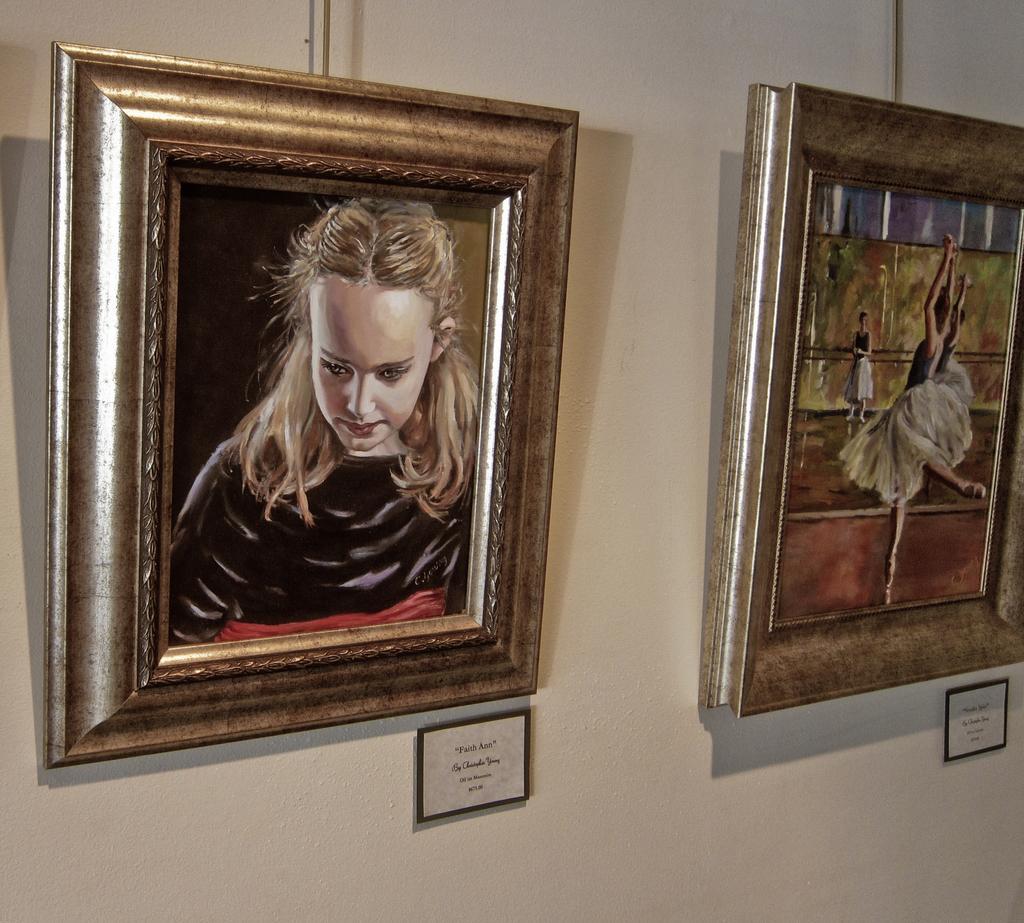How would you summarize this image in a sentence or two? In this image we can see two picture frames with painting and under the frames there are boards with text to the wall. 